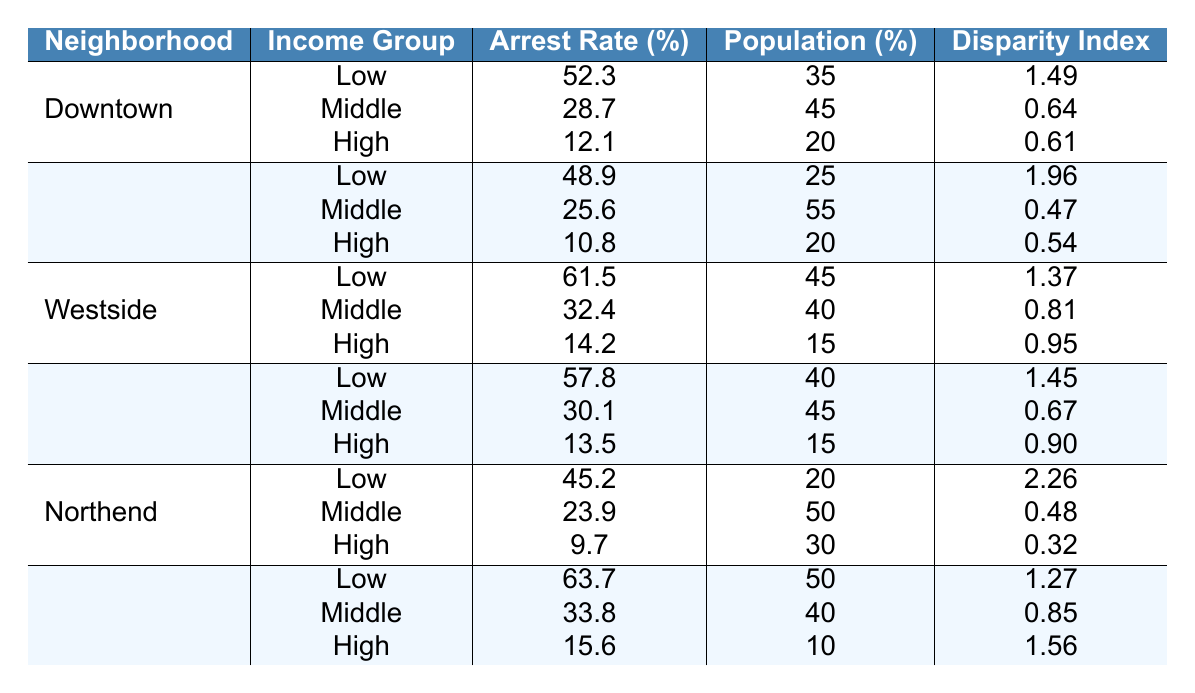What is the arrest rate for low-income individuals in the Downtown neighborhood? According to the table, the arrest rate for low-income individuals in Downtown is specifically listed as 52.3%.
Answer: 52.3% Which neighborhood has the highest arrest rate for high-income individuals? From the table, the Southside has the highest arrest rate for high-income individuals at 15.6%.
Answer: Southside What is the disparity index for the Northend's low-income group? The table shows that the disparity index for the Northend's low-income group is 2.26, indicating a significant disparity in arrest rates compared to the population percentage.
Answer: 2.26 What is the average arrest rate for middle-income individuals across all neighborhoods? The middle-income arrest rates are 28.7 (Downtown), 25.6 (Midtown), 32.4 (Westside), 30.1 (Eastside), 23.9 (Northend), and 33.8 (Southside). The total is 174.5, and there are 6 neighborhoods, so the average is 174.5/6 = 29.08.
Answer: 29.08 True or False: The arrest rate for low-income individuals in the Westside is lower than in the Southside. The arrest rate for low-income individuals in the Westside is 61.5%, while in the Southside, it's 63.7%, meaning the statement is false.
Answer: False How does the arrest rate for high-income individuals in Midtown compare to that in Eastside? The arrest rate for high-income individuals in Midtown is 10.8%, while in Eastside, it is 13.5%. Therefore, Eastside has a higher rate by 2.7%.
Answer: Eastside Which neighborhood has the lowest arrest rate for middle-income individuals? The table indicates that the lowest arrest rate for middle-income individuals is in Midtown at 25.6%.
Answer: Midtown Calculate the total percentage of low-income individuals across all neighborhoods. The percentages are 35 (Downtown), 25 (Midtown), 45 (Westside), 40 (Eastside), 20 (Northend), and 50 (Southside). Summing these gives a total of 215% across all neighborhoods.
Answer: 215% How do the arrest rates for low-income groups compare between Southside and Northend? Southside has an arrest rate of 63.7% for low-income groups, while Northend has 45.2%. Southside's rate is higher by 18.5%.
Answer: Southside has a higher rate Identify the neighborhood with the largest disparity index for low-income arrest rates. The largest disparity index for low-income arrest rates is found in the Northend, which has a disparity index of 2.26.
Answer: Northend 